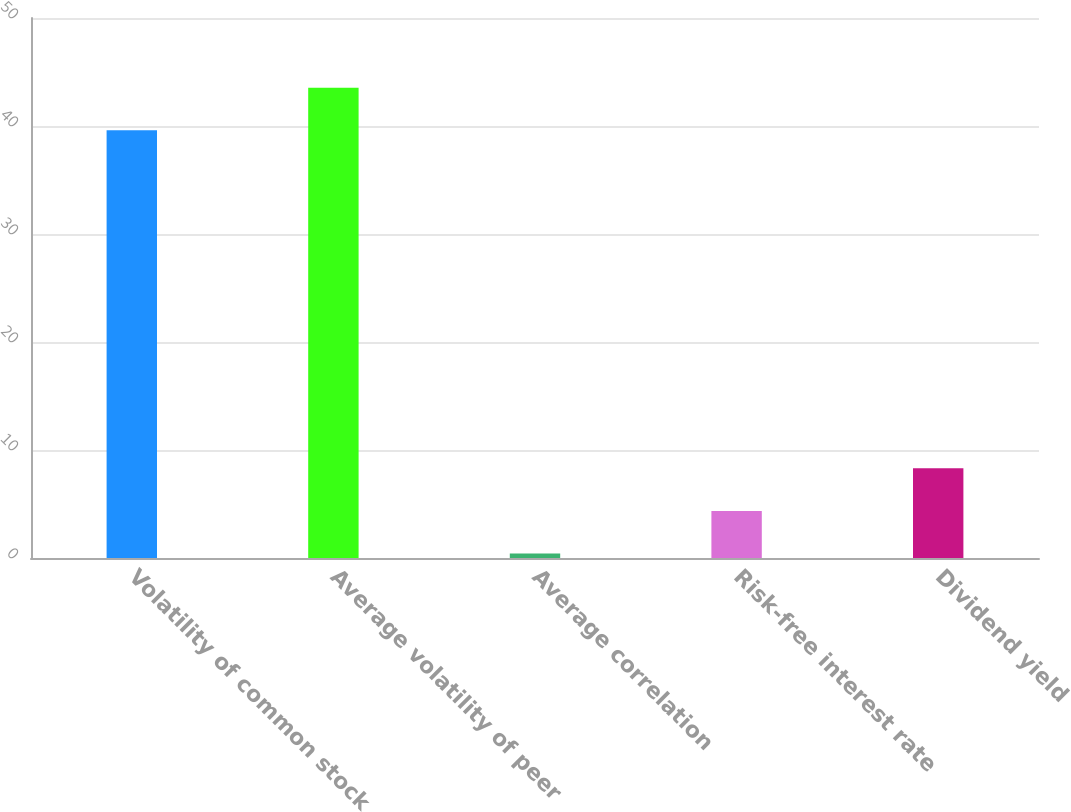Convert chart. <chart><loc_0><loc_0><loc_500><loc_500><bar_chart><fcel>Volatility of common stock<fcel>Average volatility of peer<fcel>Average correlation<fcel>Risk-free interest rate<fcel>Dividend yield<nl><fcel>39.6<fcel>43.54<fcel>0.42<fcel>4.36<fcel>8.3<nl></chart> 